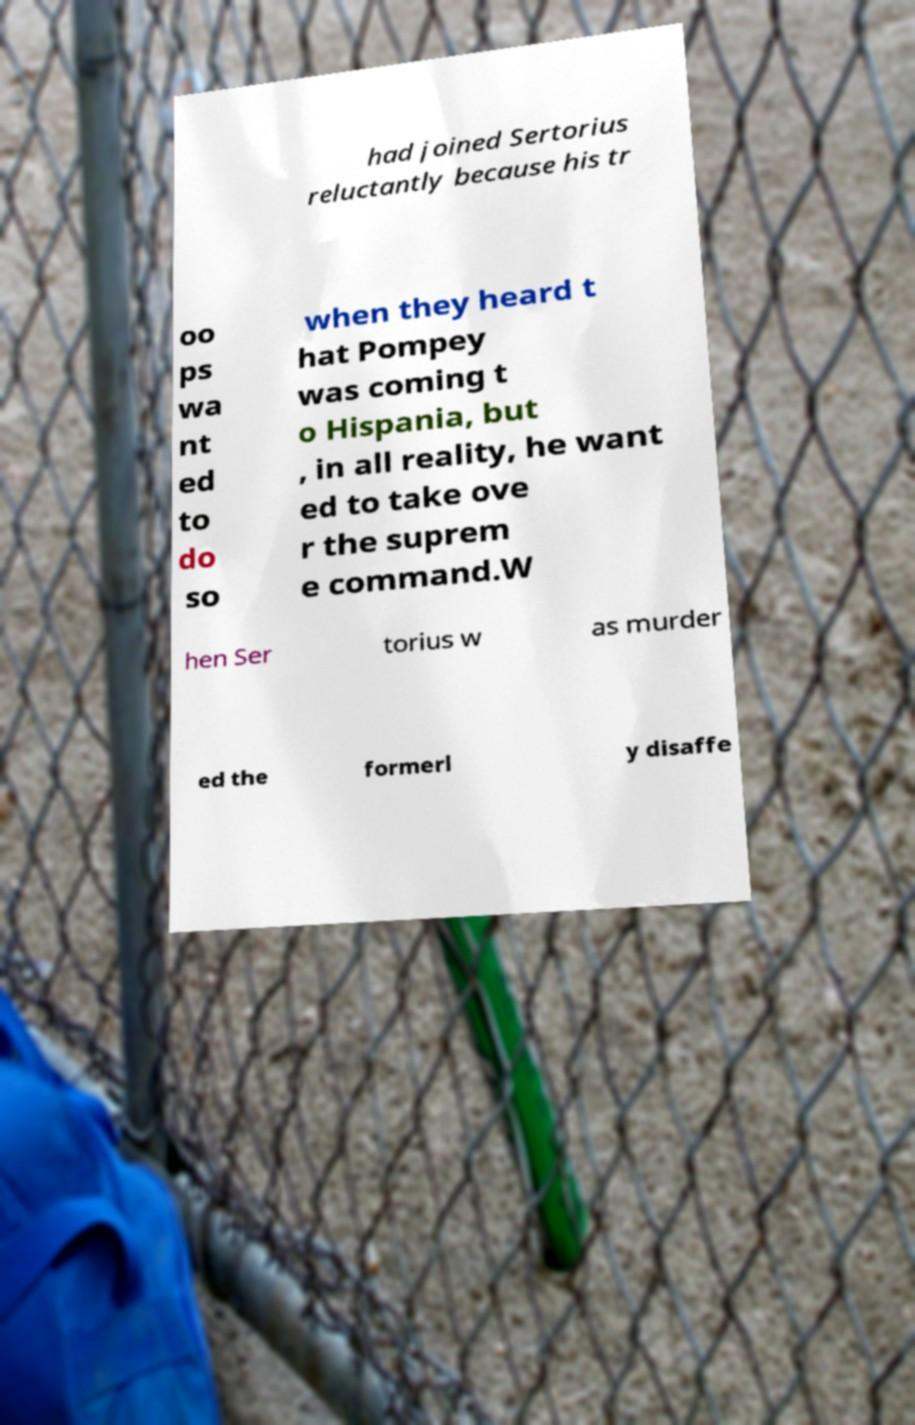Please identify and transcribe the text found in this image. had joined Sertorius reluctantly because his tr oo ps wa nt ed to do so when they heard t hat Pompey was coming t o Hispania, but , in all reality, he want ed to take ove r the suprem e command.W hen Ser torius w as murder ed the formerl y disaffe 